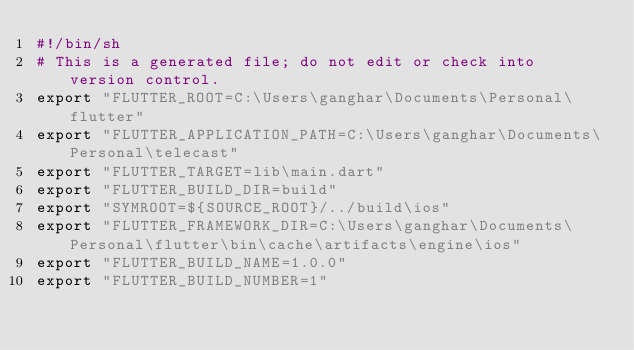Convert code to text. <code><loc_0><loc_0><loc_500><loc_500><_Bash_>#!/bin/sh
# This is a generated file; do not edit or check into version control.
export "FLUTTER_ROOT=C:\Users\ganghar\Documents\Personal\flutter"
export "FLUTTER_APPLICATION_PATH=C:\Users\ganghar\Documents\Personal\telecast"
export "FLUTTER_TARGET=lib\main.dart"
export "FLUTTER_BUILD_DIR=build"
export "SYMROOT=${SOURCE_ROOT}/../build\ios"
export "FLUTTER_FRAMEWORK_DIR=C:\Users\ganghar\Documents\Personal\flutter\bin\cache\artifacts\engine\ios"
export "FLUTTER_BUILD_NAME=1.0.0"
export "FLUTTER_BUILD_NUMBER=1"
</code> 